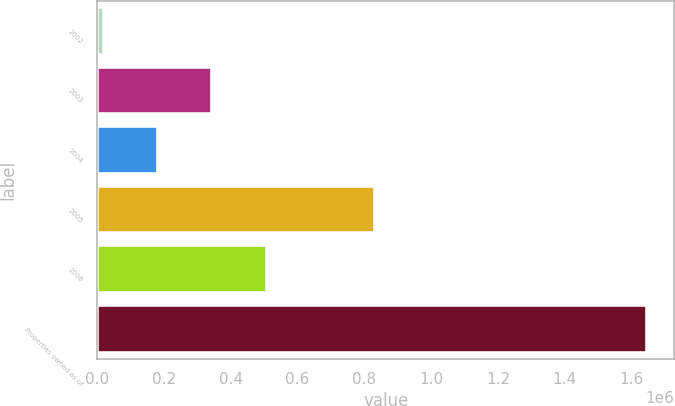Convert chart to OTSL. <chart><loc_0><loc_0><loc_500><loc_500><bar_chart><fcel>2002<fcel>2003<fcel>2004<fcel>2005<fcel>2006<fcel>Properties owned as of<nl><fcel>19890<fcel>345163<fcel>182526<fcel>832252<fcel>507800<fcel>1.64626e+06<nl></chart> 